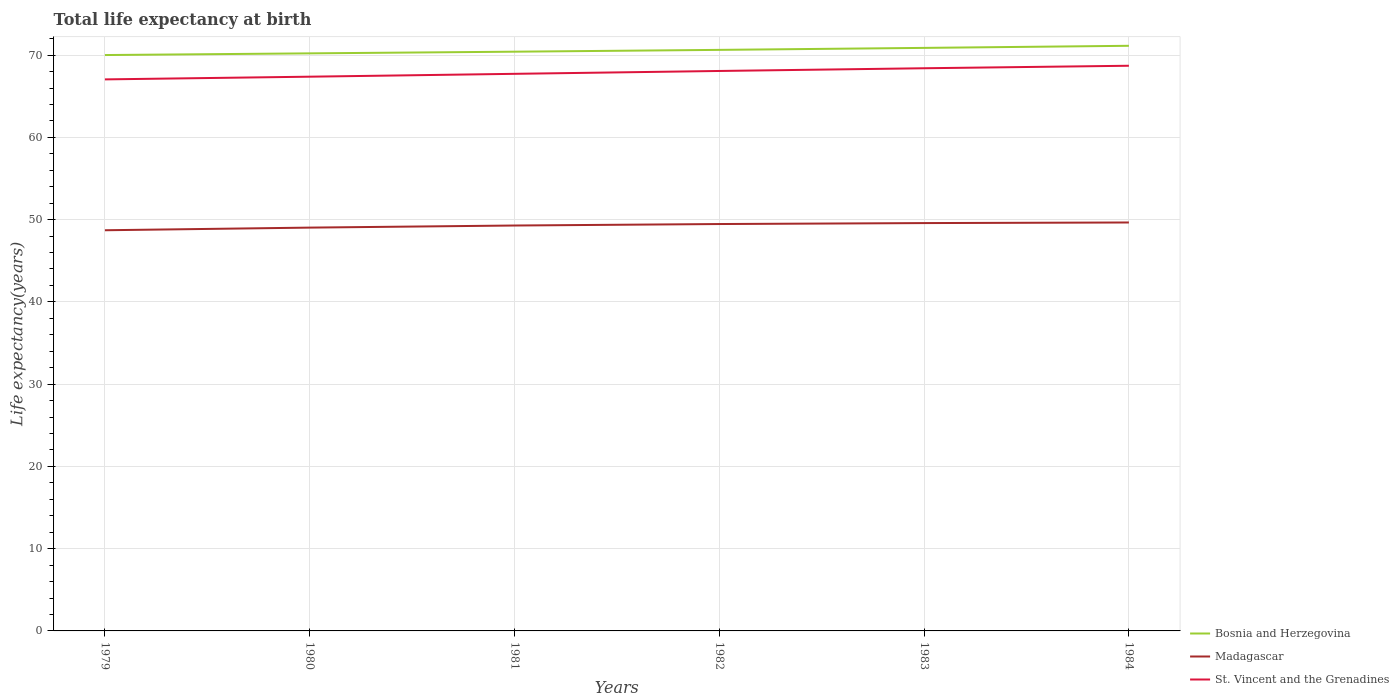Does the line corresponding to Madagascar intersect with the line corresponding to St. Vincent and the Grenadines?
Provide a short and direct response. No. Across all years, what is the maximum life expectancy at birth in in Bosnia and Herzegovina?
Offer a terse response. 70.01. In which year was the life expectancy at birth in in Bosnia and Herzegovina maximum?
Your answer should be very brief. 1979. What is the total life expectancy at birth in in Madagascar in the graph?
Ensure brevity in your answer.  -0.19. What is the difference between the highest and the second highest life expectancy at birth in in Bosnia and Herzegovina?
Give a very brief answer. 1.12. Does the graph contain any zero values?
Your answer should be very brief. No. What is the title of the graph?
Keep it short and to the point. Total life expectancy at birth. Does "Slovak Republic" appear as one of the legend labels in the graph?
Give a very brief answer. No. What is the label or title of the Y-axis?
Keep it short and to the point. Life expectancy(years). What is the Life expectancy(years) of Bosnia and Herzegovina in 1979?
Provide a succinct answer. 70.01. What is the Life expectancy(years) in Madagascar in 1979?
Your answer should be compact. 48.71. What is the Life expectancy(years) of St. Vincent and the Grenadines in 1979?
Give a very brief answer. 67.05. What is the Life expectancy(years) of Bosnia and Herzegovina in 1980?
Your response must be concise. 70.21. What is the Life expectancy(years) of Madagascar in 1980?
Offer a terse response. 49.03. What is the Life expectancy(years) in St. Vincent and the Grenadines in 1980?
Your answer should be compact. 67.38. What is the Life expectancy(years) of Bosnia and Herzegovina in 1981?
Your answer should be very brief. 70.42. What is the Life expectancy(years) of Madagascar in 1981?
Make the answer very short. 49.28. What is the Life expectancy(years) of St. Vincent and the Grenadines in 1981?
Provide a succinct answer. 67.73. What is the Life expectancy(years) in Bosnia and Herzegovina in 1982?
Ensure brevity in your answer.  70.64. What is the Life expectancy(years) in Madagascar in 1982?
Offer a terse response. 49.47. What is the Life expectancy(years) of St. Vincent and the Grenadines in 1982?
Keep it short and to the point. 68.07. What is the Life expectancy(years) in Bosnia and Herzegovina in 1983?
Your response must be concise. 70.88. What is the Life expectancy(years) of Madagascar in 1983?
Provide a short and direct response. 49.58. What is the Life expectancy(years) in St. Vincent and the Grenadines in 1983?
Ensure brevity in your answer.  68.4. What is the Life expectancy(years) of Bosnia and Herzegovina in 1984?
Your response must be concise. 71.13. What is the Life expectancy(years) of Madagascar in 1984?
Give a very brief answer. 49.65. What is the Life expectancy(years) in St. Vincent and the Grenadines in 1984?
Your answer should be compact. 68.71. Across all years, what is the maximum Life expectancy(years) in Bosnia and Herzegovina?
Offer a terse response. 71.13. Across all years, what is the maximum Life expectancy(years) in Madagascar?
Keep it short and to the point. 49.65. Across all years, what is the maximum Life expectancy(years) in St. Vincent and the Grenadines?
Offer a terse response. 68.71. Across all years, what is the minimum Life expectancy(years) in Bosnia and Herzegovina?
Your answer should be very brief. 70.01. Across all years, what is the minimum Life expectancy(years) of Madagascar?
Provide a succinct answer. 48.71. Across all years, what is the minimum Life expectancy(years) in St. Vincent and the Grenadines?
Offer a very short reply. 67.05. What is the total Life expectancy(years) of Bosnia and Herzegovina in the graph?
Give a very brief answer. 423.29. What is the total Life expectancy(years) in Madagascar in the graph?
Give a very brief answer. 295.72. What is the total Life expectancy(years) in St. Vincent and the Grenadines in the graph?
Make the answer very short. 407.33. What is the difference between the Life expectancy(years) of Bosnia and Herzegovina in 1979 and that in 1980?
Ensure brevity in your answer.  -0.21. What is the difference between the Life expectancy(years) in Madagascar in 1979 and that in 1980?
Your response must be concise. -0.32. What is the difference between the Life expectancy(years) of St. Vincent and the Grenadines in 1979 and that in 1980?
Make the answer very short. -0.33. What is the difference between the Life expectancy(years) of Bosnia and Herzegovina in 1979 and that in 1981?
Your response must be concise. -0.41. What is the difference between the Life expectancy(years) in Madagascar in 1979 and that in 1981?
Keep it short and to the point. -0.58. What is the difference between the Life expectancy(years) of St. Vincent and the Grenadines in 1979 and that in 1981?
Your response must be concise. -0.68. What is the difference between the Life expectancy(years) in Bosnia and Herzegovina in 1979 and that in 1982?
Offer a very short reply. -0.63. What is the difference between the Life expectancy(years) in Madagascar in 1979 and that in 1982?
Make the answer very short. -0.76. What is the difference between the Life expectancy(years) in St. Vincent and the Grenadines in 1979 and that in 1982?
Your response must be concise. -1.02. What is the difference between the Life expectancy(years) of Bosnia and Herzegovina in 1979 and that in 1983?
Provide a succinct answer. -0.87. What is the difference between the Life expectancy(years) in Madagascar in 1979 and that in 1983?
Your answer should be compact. -0.87. What is the difference between the Life expectancy(years) in St. Vincent and the Grenadines in 1979 and that in 1983?
Keep it short and to the point. -1.35. What is the difference between the Life expectancy(years) of Bosnia and Herzegovina in 1979 and that in 1984?
Your answer should be very brief. -1.12. What is the difference between the Life expectancy(years) in Madagascar in 1979 and that in 1984?
Provide a succinct answer. -0.94. What is the difference between the Life expectancy(years) in St. Vincent and the Grenadines in 1979 and that in 1984?
Your answer should be very brief. -1.66. What is the difference between the Life expectancy(years) in Bosnia and Herzegovina in 1980 and that in 1981?
Keep it short and to the point. -0.2. What is the difference between the Life expectancy(years) in Madagascar in 1980 and that in 1981?
Give a very brief answer. -0.25. What is the difference between the Life expectancy(years) of St. Vincent and the Grenadines in 1980 and that in 1981?
Make the answer very short. -0.35. What is the difference between the Life expectancy(years) of Bosnia and Herzegovina in 1980 and that in 1982?
Provide a short and direct response. -0.42. What is the difference between the Life expectancy(years) of Madagascar in 1980 and that in 1982?
Provide a succinct answer. -0.43. What is the difference between the Life expectancy(years) of St. Vincent and the Grenadines in 1980 and that in 1982?
Your answer should be very brief. -0.7. What is the difference between the Life expectancy(years) in Bosnia and Herzegovina in 1980 and that in 1983?
Provide a short and direct response. -0.67. What is the difference between the Life expectancy(years) of Madagascar in 1980 and that in 1983?
Give a very brief answer. -0.55. What is the difference between the Life expectancy(years) of St. Vincent and the Grenadines in 1980 and that in 1983?
Keep it short and to the point. -1.03. What is the difference between the Life expectancy(years) in Bosnia and Herzegovina in 1980 and that in 1984?
Offer a terse response. -0.92. What is the difference between the Life expectancy(years) of Madagascar in 1980 and that in 1984?
Provide a short and direct response. -0.62. What is the difference between the Life expectancy(years) of St. Vincent and the Grenadines in 1980 and that in 1984?
Offer a very short reply. -1.33. What is the difference between the Life expectancy(years) in Bosnia and Herzegovina in 1981 and that in 1982?
Make the answer very short. -0.22. What is the difference between the Life expectancy(years) in Madagascar in 1981 and that in 1982?
Offer a terse response. -0.18. What is the difference between the Life expectancy(years) in St. Vincent and the Grenadines in 1981 and that in 1982?
Keep it short and to the point. -0.35. What is the difference between the Life expectancy(years) of Bosnia and Herzegovina in 1981 and that in 1983?
Your response must be concise. -0.46. What is the difference between the Life expectancy(years) of Madagascar in 1981 and that in 1983?
Offer a terse response. -0.3. What is the difference between the Life expectancy(years) of St. Vincent and the Grenadines in 1981 and that in 1983?
Give a very brief answer. -0.68. What is the difference between the Life expectancy(years) of Bosnia and Herzegovina in 1981 and that in 1984?
Give a very brief answer. -0.72. What is the difference between the Life expectancy(years) of Madagascar in 1981 and that in 1984?
Keep it short and to the point. -0.37. What is the difference between the Life expectancy(years) of St. Vincent and the Grenadines in 1981 and that in 1984?
Offer a very short reply. -0.98. What is the difference between the Life expectancy(years) of Bosnia and Herzegovina in 1982 and that in 1983?
Offer a very short reply. -0.24. What is the difference between the Life expectancy(years) in Madagascar in 1982 and that in 1983?
Provide a succinct answer. -0.12. What is the difference between the Life expectancy(years) in St. Vincent and the Grenadines in 1982 and that in 1983?
Your answer should be very brief. -0.33. What is the difference between the Life expectancy(years) in Bosnia and Herzegovina in 1982 and that in 1984?
Offer a terse response. -0.5. What is the difference between the Life expectancy(years) in Madagascar in 1982 and that in 1984?
Keep it short and to the point. -0.19. What is the difference between the Life expectancy(years) of St. Vincent and the Grenadines in 1982 and that in 1984?
Give a very brief answer. -0.63. What is the difference between the Life expectancy(years) of Bosnia and Herzegovina in 1983 and that in 1984?
Your response must be concise. -0.25. What is the difference between the Life expectancy(years) of Madagascar in 1983 and that in 1984?
Your answer should be compact. -0.07. What is the difference between the Life expectancy(years) in St. Vincent and the Grenadines in 1983 and that in 1984?
Give a very brief answer. -0.3. What is the difference between the Life expectancy(years) in Bosnia and Herzegovina in 1979 and the Life expectancy(years) in Madagascar in 1980?
Provide a succinct answer. 20.98. What is the difference between the Life expectancy(years) in Bosnia and Herzegovina in 1979 and the Life expectancy(years) in St. Vincent and the Grenadines in 1980?
Offer a very short reply. 2.63. What is the difference between the Life expectancy(years) in Madagascar in 1979 and the Life expectancy(years) in St. Vincent and the Grenadines in 1980?
Your answer should be compact. -18.67. What is the difference between the Life expectancy(years) in Bosnia and Herzegovina in 1979 and the Life expectancy(years) in Madagascar in 1981?
Provide a short and direct response. 20.72. What is the difference between the Life expectancy(years) in Bosnia and Herzegovina in 1979 and the Life expectancy(years) in St. Vincent and the Grenadines in 1981?
Ensure brevity in your answer.  2.28. What is the difference between the Life expectancy(years) in Madagascar in 1979 and the Life expectancy(years) in St. Vincent and the Grenadines in 1981?
Ensure brevity in your answer.  -19.02. What is the difference between the Life expectancy(years) of Bosnia and Herzegovina in 1979 and the Life expectancy(years) of Madagascar in 1982?
Provide a succinct answer. 20.54. What is the difference between the Life expectancy(years) of Bosnia and Herzegovina in 1979 and the Life expectancy(years) of St. Vincent and the Grenadines in 1982?
Offer a terse response. 1.93. What is the difference between the Life expectancy(years) in Madagascar in 1979 and the Life expectancy(years) in St. Vincent and the Grenadines in 1982?
Keep it short and to the point. -19.36. What is the difference between the Life expectancy(years) in Bosnia and Herzegovina in 1979 and the Life expectancy(years) in Madagascar in 1983?
Offer a terse response. 20.43. What is the difference between the Life expectancy(years) in Bosnia and Herzegovina in 1979 and the Life expectancy(years) in St. Vincent and the Grenadines in 1983?
Ensure brevity in your answer.  1.6. What is the difference between the Life expectancy(years) in Madagascar in 1979 and the Life expectancy(years) in St. Vincent and the Grenadines in 1983?
Keep it short and to the point. -19.69. What is the difference between the Life expectancy(years) in Bosnia and Herzegovina in 1979 and the Life expectancy(years) in Madagascar in 1984?
Offer a terse response. 20.36. What is the difference between the Life expectancy(years) in Bosnia and Herzegovina in 1979 and the Life expectancy(years) in St. Vincent and the Grenadines in 1984?
Your response must be concise. 1.3. What is the difference between the Life expectancy(years) in Madagascar in 1979 and the Life expectancy(years) in St. Vincent and the Grenadines in 1984?
Offer a very short reply. -20. What is the difference between the Life expectancy(years) of Bosnia and Herzegovina in 1980 and the Life expectancy(years) of Madagascar in 1981?
Your answer should be very brief. 20.93. What is the difference between the Life expectancy(years) of Bosnia and Herzegovina in 1980 and the Life expectancy(years) of St. Vincent and the Grenadines in 1981?
Ensure brevity in your answer.  2.49. What is the difference between the Life expectancy(years) of Madagascar in 1980 and the Life expectancy(years) of St. Vincent and the Grenadines in 1981?
Give a very brief answer. -18.69. What is the difference between the Life expectancy(years) of Bosnia and Herzegovina in 1980 and the Life expectancy(years) of Madagascar in 1982?
Offer a very short reply. 20.75. What is the difference between the Life expectancy(years) in Bosnia and Herzegovina in 1980 and the Life expectancy(years) in St. Vincent and the Grenadines in 1982?
Your answer should be compact. 2.14. What is the difference between the Life expectancy(years) in Madagascar in 1980 and the Life expectancy(years) in St. Vincent and the Grenadines in 1982?
Keep it short and to the point. -19.04. What is the difference between the Life expectancy(years) of Bosnia and Herzegovina in 1980 and the Life expectancy(years) of Madagascar in 1983?
Make the answer very short. 20.63. What is the difference between the Life expectancy(years) of Bosnia and Herzegovina in 1980 and the Life expectancy(years) of St. Vincent and the Grenadines in 1983?
Give a very brief answer. 1.81. What is the difference between the Life expectancy(years) of Madagascar in 1980 and the Life expectancy(years) of St. Vincent and the Grenadines in 1983?
Offer a very short reply. -19.37. What is the difference between the Life expectancy(years) of Bosnia and Herzegovina in 1980 and the Life expectancy(years) of Madagascar in 1984?
Give a very brief answer. 20.56. What is the difference between the Life expectancy(years) of Bosnia and Herzegovina in 1980 and the Life expectancy(years) of St. Vincent and the Grenadines in 1984?
Offer a terse response. 1.51. What is the difference between the Life expectancy(years) in Madagascar in 1980 and the Life expectancy(years) in St. Vincent and the Grenadines in 1984?
Your answer should be compact. -19.68. What is the difference between the Life expectancy(years) of Bosnia and Herzegovina in 1981 and the Life expectancy(years) of Madagascar in 1982?
Offer a very short reply. 20.95. What is the difference between the Life expectancy(years) of Bosnia and Herzegovina in 1981 and the Life expectancy(years) of St. Vincent and the Grenadines in 1982?
Offer a very short reply. 2.34. What is the difference between the Life expectancy(years) in Madagascar in 1981 and the Life expectancy(years) in St. Vincent and the Grenadines in 1982?
Your answer should be compact. -18.79. What is the difference between the Life expectancy(years) of Bosnia and Herzegovina in 1981 and the Life expectancy(years) of Madagascar in 1983?
Offer a terse response. 20.84. What is the difference between the Life expectancy(years) of Bosnia and Herzegovina in 1981 and the Life expectancy(years) of St. Vincent and the Grenadines in 1983?
Provide a succinct answer. 2.01. What is the difference between the Life expectancy(years) of Madagascar in 1981 and the Life expectancy(years) of St. Vincent and the Grenadines in 1983?
Keep it short and to the point. -19.12. What is the difference between the Life expectancy(years) in Bosnia and Herzegovina in 1981 and the Life expectancy(years) in Madagascar in 1984?
Your answer should be compact. 20.77. What is the difference between the Life expectancy(years) in Bosnia and Herzegovina in 1981 and the Life expectancy(years) in St. Vincent and the Grenadines in 1984?
Your answer should be compact. 1.71. What is the difference between the Life expectancy(years) of Madagascar in 1981 and the Life expectancy(years) of St. Vincent and the Grenadines in 1984?
Keep it short and to the point. -19.42. What is the difference between the Life expectancy(years) in Bosnia and Herzegovina in 1982 and the Life expectancy(years) in Madagascar in 1983?
Ensure brevity in your answer.  21.06. What is the difference between the Life expectancy(years) in Bosnia and Herzegovina in 1982 and the Life expectancy(years) in St. Vincent and the Grenadines in 1983?
Provide a short and direct response. 2.23. What is the difference between the Life expectancy(years) in Madagascar in 1982 and the Life expectancy(years) in St. Vincent and the Grenadines in 1983?
Your response must be concise. -18.94. What is the difference between the Life expectancy(years) in Bosnia and Herzegovina in 1982 and the Life expectancy(years) in Madagascar in 1984?
Offer a terse response. 20.98. What is the difference between the Life expectancy(years) in Bosnia and Herzegovina in 1982 and the Life expectancy(years) in St. Vincent and the Grenadines in 1984?
Make the answer very short. 1.93. What is the difference between the Life expectancy(years) in Madagascar in 1982 and the Life expectancy(years) in St. Vincent and the Grenadines in 1984?
Your answer should be compact. -19.24. What is the difference between the Life expectancy(years) of Bosnia and Herzegovina in 1983 and the Life expectancy(years) of Madagascar in 1984?
Make the answer very short. 21.23. What is the difference between the Life expectancy(years) of Bosnia and Herzegovina in 1983 and the Life expectancy(years) of St. Vincent and the Grenadines in 1984?
Offer a very short reply. 2.17. What is the difference between the Life expectancy(years) in Madagascar in 1983 and the Life expectancy(years) in St. Vincent and the Grenadines in 1984?
Make the answer very short. -19.13. What is the average Life expectancy(years) of Bosnia and Herzegovina per year?
Keep it short and to the point. 70.55. What is the average Life expectancy(years) of Madagascar per year?
Offer a terse response. 49.29. What is the average Life expectancy(years) in St. Vincent and the Grenadines per year?
Provide a short and direct response. 67.89. In the year 1979, what is the difference between the Life expectancy(years) in Bosnia and Herzegovina and Life expectancy(years) in Madagascar?
Provide a short and direct response. 21.3. In the year 1979, what is the difference between the Life expectancy(years) of Bosnia and Herzegovina and Life expectancy(years) of St. Vincent and the Grenadines?
Keep it short and to the point. 2.96. In the year 1979, what is the difference between the Life expectancy(years) in Madagascar and Life expectancy(years) in St. Vincent and the Grenadines?
Provide a succinct answer. -18.34. In the year 1980, what is the difference between the Life expectancy(years) in Bosnia and Herzegovina and Life expectancy(years) in Madagascar?
Your answer should be compact. 21.18. In the year 1980, what is the difference between the Life expectancy(years) in Bosnia and Herzegovina and Life expectancy(years) in St. Vincent and the Grenadines?
Make the answer very short. 2.84. In the year 1980, what is the difference between the Life expectancy(years) of Madagascar and Life expectancy(years) of St. Vincent and the Grenadines?
Keep it short and to the point. -18.35. In the year 1981, what is the difference between the Life expectancy(years) in Bosnia and Herzegovina and Life expectancy(years) in Madagascar?
Give a very brief answer. 21.13. In the year 1981, what is the difference between the Life expectancy(years) of Bosnia and Herzegovina and Life expectancy(years) of St. Vincent and the Grenadines?
Your answer should be compact. 2.69. In the year 1981, what is the difference between the Life expectancy(years) in Madagascar and Life expectancy(years) in St. Vincent and the Grenadines?
Your answer should be very brief. -18.44. In the year 1982, what is the difference between the Life expectancy(years) of Bosnia and Herzegovina and Life expectancy(years) of Madagascar?
Keep it short and to the point. 21.17. In the year 1982, what is the difference between the Life expectancy(years) in Bosnia and Herzegovina and Life expectancy(years) in St. Vincent and the Grenadines?
Give a very brief answer. 2.56. In the year 1982, what is the difference between the Life expectancy(years) in Madagascar and Life expectancy(years) in St. Vincent and the Grenadines?
Provide a succinct answer. -18.61. In the year 1983, what is the difference between the Life expectancy(years) of Bosnia and Herzegovina and Life expectancy(years) of Madagascar?
Ensure brevity in your answer.  21.3. In the year 1983, what is the difference between the Life expectancy(years) of Bosnia and Herzegovina and Life expectancy(years) of St. Vincent and the Grenadines?
Provide a succinct answer. 2.48. In the year 1983, what is the difference between the Life expectancy(years) of Madagascar and Life expectancy(years) of St. Vincent and the Grenadines?
Provide a short and direct response. -18.82. In the year 1984, what is the difference between the Life expectancy(years) in Bosnia and Herzegovina and Life expectancy(years) in Madagascar?
Your response must be concise. 21.48. In the year 1984, what is the difference between the Life expectancy(years) of Bosnia and Herzegovina and Life expectancy(years) of St. Vincent and the Grenadines?
Ensure brevity in your answer.  2.43. In the year 1984, what is the difference between the Life expectancy(years) in Madagascar and Life expectancy(years) in St. Vincent and the Grenadines?
Provide a short and direct response. -19.06. What is the ratio of the Life expectancy(years) of St. Vincent and the Grenadines in 1979 to that in 1980?
Your response must be concise. 1. What is the ratio of the Life expectancy(years) of Bosnia and Herzegovina in 1979 to that in 1981?
Give a very brief answer. 0.99. What is the ratio of the Life expectancy(years) in Madagascar in 1979 to that in 1981?
Keep it short and to the point. 0.99. What is the ratio of the Life expectancy(years) in Bosnia and Herzegovina in 1979 to that in 1982?
Offer a very short reply. 0.99. What is the ratio of the Life expectancy(years) of Madagascar in 1979 to that in 1982?
Your answer should be compact. 0.98. What is the ratio of the Life expectancy(years) in St. Vincent and the Grenadines in 1979 to that in 1982?
Your answer should be very brief. 0.98. What is the ratio of the Life expectancy(years) in Madagascar in 1979 to that in 1983?
Give a very brief answer. 0.98. What is the ratio of the Life expectancy(years) of St. Vincent and the Grenadines in 1979 to that in 1983?
Ensure brevity in your answer.  0.98. What is the ratio of the Life expectancy(years) of Bosnia and Herzegovina in 1979 to that in 1984?
Provide a succinct answer. 0.98. What is the ratio of the Life expectancy(years) in St. Vincent and the Grenadines in 1979 to that in 1984?
Offer a terse response. 0.98. What is the ratio of the Life expectancy(years) in St. Vincent and the Grenadines in 1980 to that in 1981?
Ensure brevity in your answer.  0.99. What is the ratio of the Life expectancy(years) in St. Vincent and the Grenadines in 1980 to that in 1982?
Your response must be concise. 0.99. What is the ratio of the Life expectancy(years) in Bosnia and Herzegovina in 1980 to that in 1983?
Keep it short and to the point. 0.99. What is the ratio of the Life expectancy(years) in Madagascar in 1980 to that in 1983?
Your response must be concise. 0.99. What is the ratio of the Life expectancy(years) in St. Vincent and the Grenadines in 1980 to that in 1983?
Provide a succinct answer. 0.98. What is the ratio of the Life expectancy(years) of Bosnia and Herzegovina in 1980 to that in 1984?
Keep it short and to the point. 0.99. What is the ratio of the Life expectancy(years) in Madagascar in 1980 to that in 1984?
Your response must be concise. 0.99. What is the ratio of the Life expectancy(years) in St. Vincent and the Grenadines in 1980 to that in 1984?
Your response must be concise. 0.98. What is the ratio of the Life expectancy(years) of St. Vincent and the Grenadines in 1981 to that in 1984?
Your response must be concise. 0.99. What is the ratio of the Life expectancy(years) in Bosnia and Herzegovina in 1982 to that in 1983?
Offer a terse response. 1. What is the ratio of the Life expectancy(years) of St. Vincent and the Grenadines in 1982 to that in 1983?
Make the answer very short. 1. What is the ratio of the Life expectancy(years) in Madagascar in 1982 to that in 1984?
Your answer should be compact. 1. What is the ratio of the Life expectancy(years) of Bosnia and Herzegovina in 1983 to that in 1984?
Give a very brief answer. 1. What is the difference between the highest and the second highest Life expectancy(years) in Bosnia and Herzegovina?
Your answer should be very brief. 0.25. What is the difference between the highest and the second highest Life expectancy(years) of Madagascar?
Provide a short and direct response. 0.07. What is the difference between the highest and the second highest Life expectancy(years) of St. Vincent and the Grenadines?
Your answer should be very brief. 0.3. What is the difference between the highest and the lowest Life expectancy(years) in Madagascar?
Provide a short and direct response. 0.94. What is the difference between the highest and the lowest Life expectancy(years) in St. Vincent and the Grenadines?
Your answer should be compact. 1.66. 